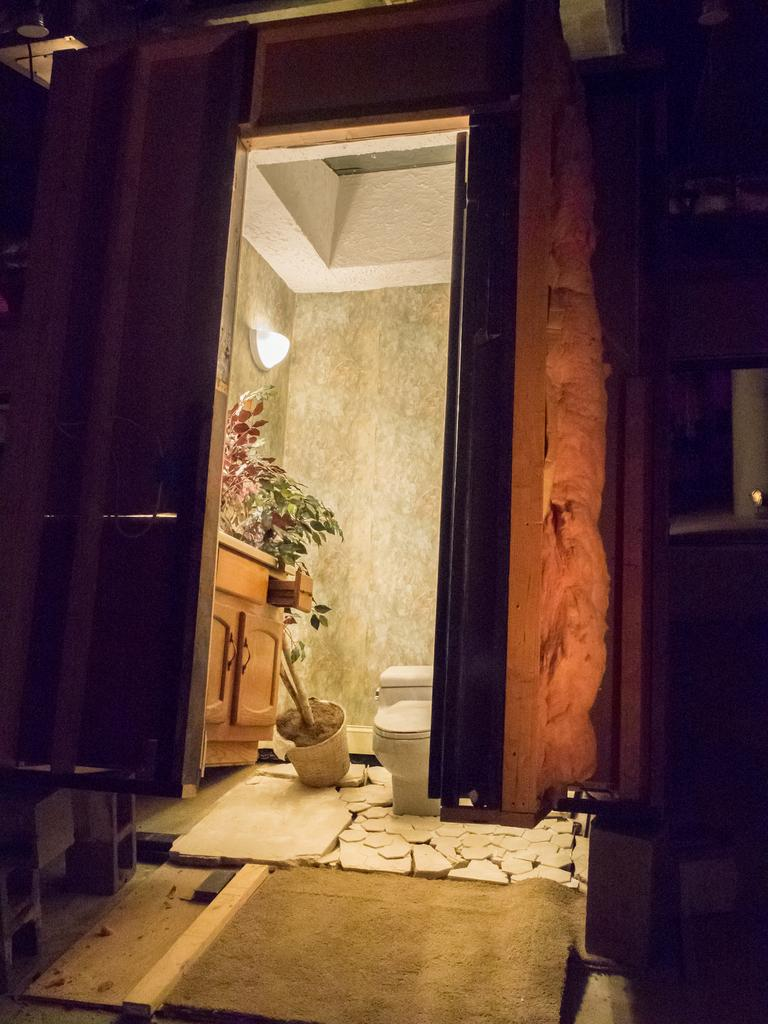What type of location is depicted in the image? The image shows an inside view of a building. What specific object can be seen in the image? There is a toilet seat in the image. Are there any decorative or living elements in the image? Yes, there is a house plant in the image. Can you describe the lighting conditions in the image? There is light visible in the image. What can be seen in the background of the image? There is a wall in the background of the image. What type of rose is being offered for peace in the image? There is no rose or any reference to peace in the image; it shows an inside view of a building with a toilet seat, house plant, light, and wall. 